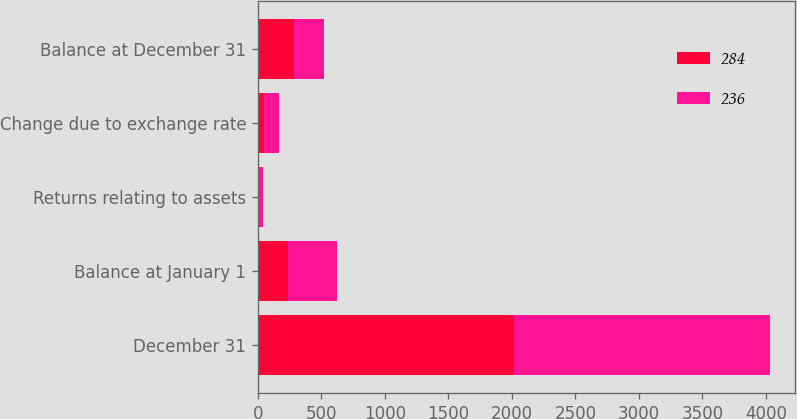<chart> <loc_0><loc_0><loc_500><loc_500><stacked_bar_chart><ecel><fcel>December 31<fcel>Balance at January 1<fcel>Returns relating to assets<fcel>Change due to exchange rate<fcel>Balance at December 31<nl><fcel>284<fcel>2016<fcel>236<fcel>3<fcel>45<fcel>284<nl><fcel>236<fcel>2015<fcel>389<fcel>35<fcel>118<fcel>236<nl></chart> 